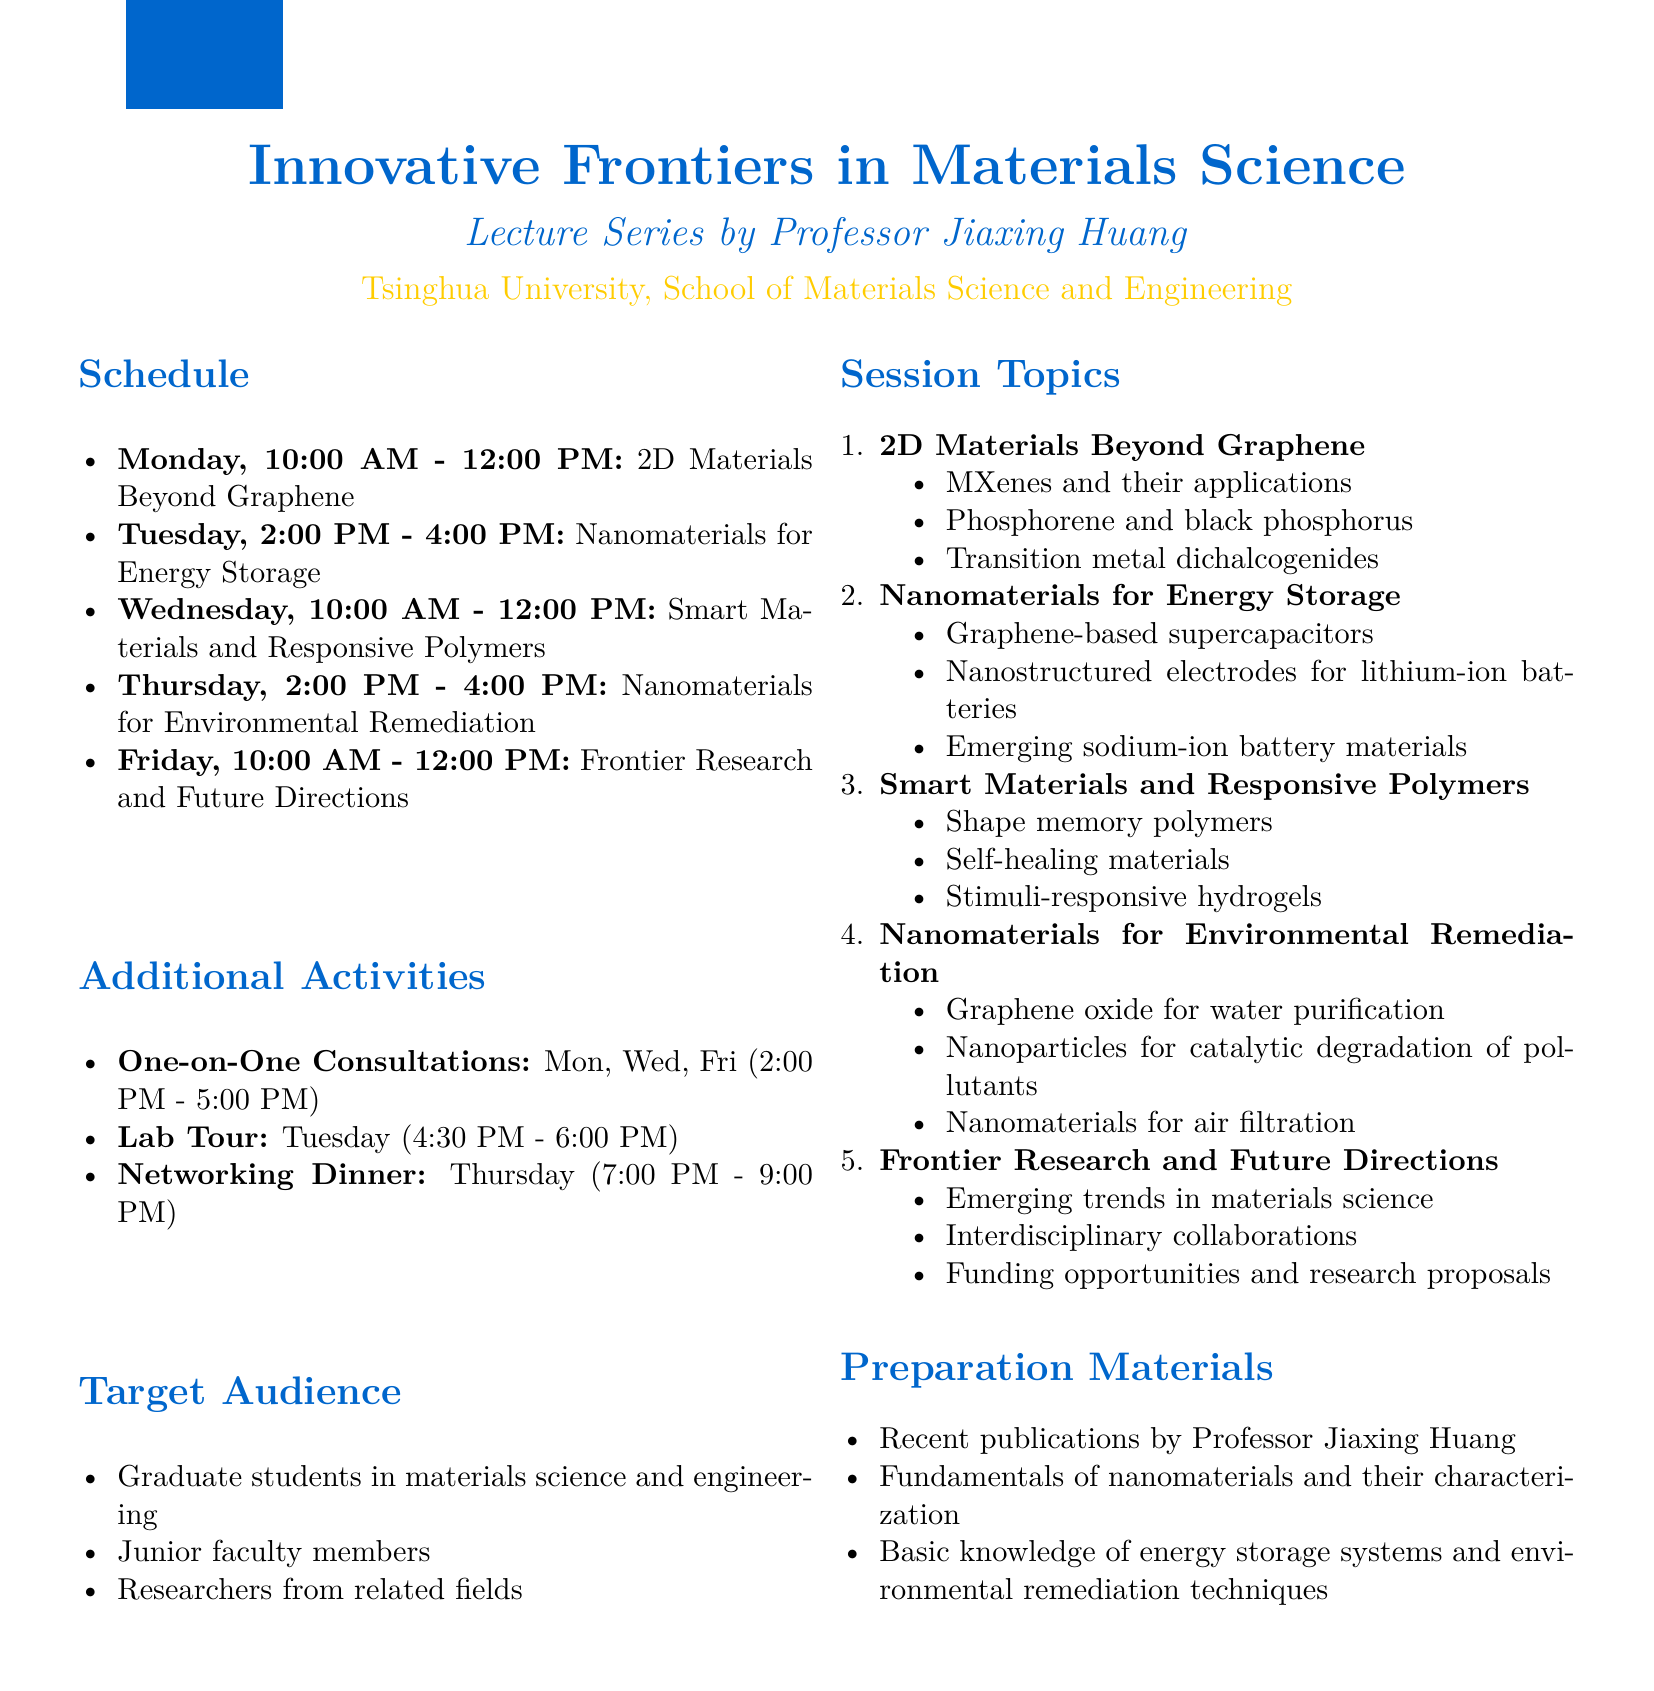What is the title of the seminar series? The title of the seminar series is clearly mentioned in the document as "Innovative Frontiers in Materials Science: Lecture Series by Professor Jiaxing Huang."
Answer: Innovative Frontiers in Materials Science: Lecture Series by Professor Jiaxing Huang When will the lecture on "Nanomaterials for Energy Storage" take place? The document specifies the day and time for the session on "Nanomaterials for Energy Storage," which is on Tuesday from 2:00 PM to 4:00 PM.
Answer: Tuesday, 2:00 PM - 4:00 PM Which topics are covered on Friday's session? The document lists the topics for Friday's session as "Frontier Research and Future Directions" and also outlines its subtopics.
Answer: Frontier Research and Future Directions What additional activity is scheduled for Tuesday after the lecture? The document mentions an additional activity, a "Lab Tour," that takes place on Tuesday from 4:30 PM to 6:00 PM.
Answer: Lab Tour Who is the target audience for the seminar series? The document includes a section detailing the target audience, which consists of graduate students, junior faculty members, and researchers from related fields.
Answer: Graduate students in materials science and engineering, Junior faculty members, Researchers from related fields How long is the seminar series scheduled to last? The document clearly indicates the seminar series is scheduled for one week.
Answer: One week What time do the one-on-one consultations with Professor Huang occur? The document provides the schedule for one-on-one consultations with Professor Huang, highlighting the days and time.
Answer: 2:00 PM - 5:00 PM What is one of the preparation materials recommended? The document lists several preparation materials recommended for participants, one of them being recent publications by Professor Jiaxing Huang.
Answer: Recent publications by Professor Jiaxing Huang 